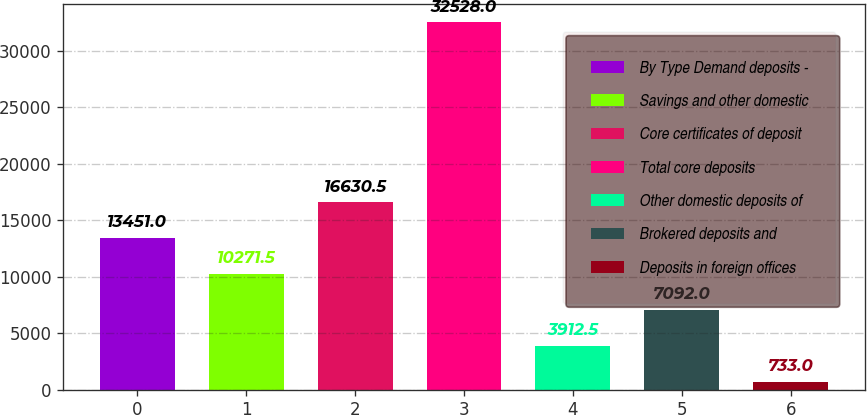<chart> <loc_0><loc_0><loc_500><loc_500><bar_chart><fcel>By Type Demand deposits -<fcel>Savings and other domestic<fcel>Core certificates of deposit<fcel>Total core deposits<fcel>Other domestic deposits of<fcel>Brokered deposits and<fcel>Deposits in foreign offices<nl><fcel>13451<fcel>10271.5<fcel>16630.5<fcel>32528<fcel>3912.5<fcel>7092<fcel>733<nl></chart> 